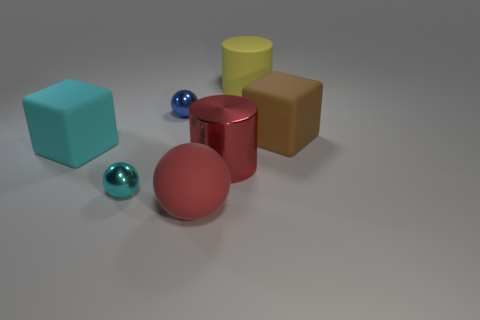There is a matte ball; are there any objects behind it?
Give a very brief answer. Yes. How many other objects are there of the same shape as the yellow object?
Provide a succinct answer. 1. The metallic object that is the same size as the yellow matte thing is what color?
Offer a very short reply. Red. Is the number of small cyan balls that are on the right side of the red metal cylinder less than the number of brown things in front of the small blue thing?
Ensure brevity in your answer.  Yes. There is a metal sphere in front of the small metal object that is behind the large red shiny thing; what number of tiny blue things are left of it?
Offer a terse response. 0. What size is the cyan rubber object that is the same shape as the large brown rubber object?
Your response must be concise. Large. Is the number of cyan balls to the left of the small cyan shiny object less than the number of red cubes?
Provide a short and direct response. No. Do the red matte thing and the small blue thing have the same shape?
Provide a succinct answer. Yes. What is the color of the other thing that is the same shape as the large brown matte object?
Ensure brevity in your answer.  Cyan. What number of metallic objects are the same color as the matte sphere?
Ensure brevity in your answer.  1. 